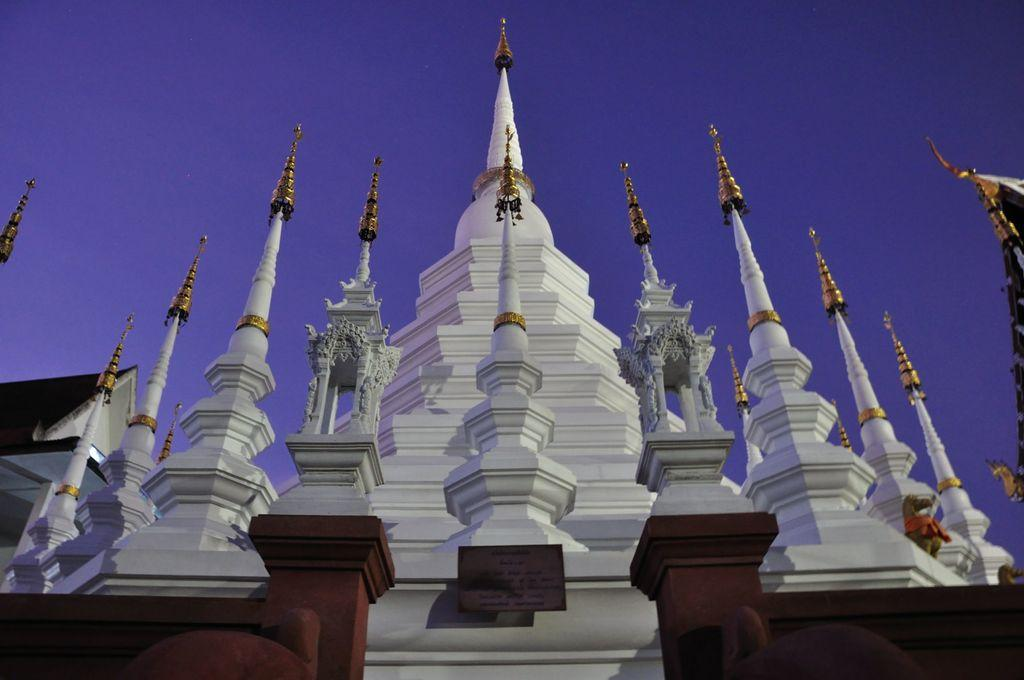What is the main structure in the image? There is a tower in the image. What can be seen in the background of the image? The sky is visible in the image. How many pizzas are being sold in the shop in the image? There is no shop or pizzas present in the image; it features a tower and the sky. What type of industry is depicted in the image? There is no industry depicted in the image; it features a tower and the sky. 